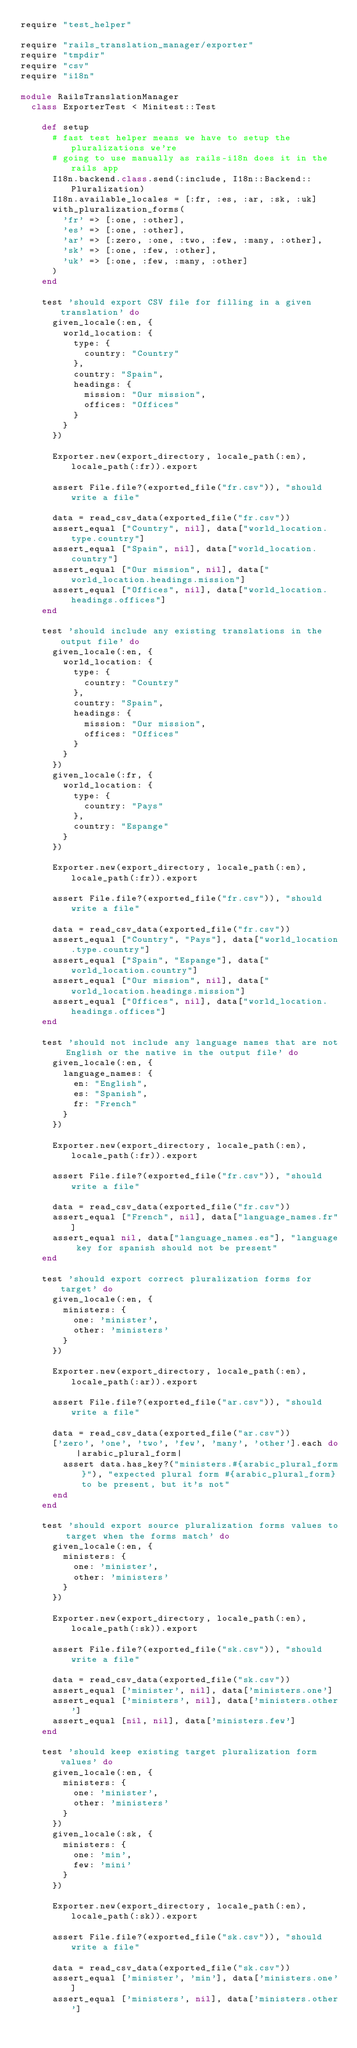Convert code to text. <code><loc_0><loc_0><loc_500><loc_500><_Ruby_>require "test_helper"

require "rails_translation_manager/exporter"
require "tmpdir"
require "csv"
require "i18n"

module RailsTranslationManager
  class ExporterTest < Minitest::Test

    def setup
      # fast test helper means we have to setup the pluralizations we're
      # going to use manually as rails-i18n does it in the rails app
      I18n.backend.class.send(:include, I18n::Backend::Pluralization)
      I18n.available_locales = [:fr, :es, :ar, :sk, :uk]
      with_pluralization_forms(
        'fr' => [:one, :other],
        'es' => [:one, :other],
        'ar' => [:zero, :one, :two, :few, :many, :other],
        'sk' => [:one, :few, :other],
        'uk' => [:one, :few, :many, :other]
      )
    end

    test 'should export CSV file for filling in a given translation' do
      given_locale(:en, {
        world_location: {
          type: {
            country: "Country"
          },
          country: "Spain",
          headings: {
            mission: "Our mission",
            offices: "Offices"
          }
        }
      })

      Exporter.new(export_directory, locale_path(:en), locale_path(:fr)).export

      assert File.file?(exported_file("fr.csv")), "should write a file"

      data = read_csv_data(exported_file("fr.csv"))
      assert_equal ["Country", nil], data["world_location.type.country"]
      assert_equal ["Spain", nil], data["world_location.country"]
      assert_equal ["Our mission", nil], data["world_location.headings.mission"]
      assert_equal ["Offices", nil], data["world_location.headings.offices"]
    end

    test 'should include any existing translations in the output file' do
      given_locale(:en, {
        world_location: {
          type: {
            country: "Country"
          },
          country: "Spain",
          headings: {
            mission: "Our mission",
            offices: "Offices"
          }
        }
      })
      given_locale(:fr, {
        world_location: {
          type: {
            country: "Pays"
          },
          country: "Espange"
        }
      })

      Exporter.new(export_directory, locale_path(:en), locale_path(:fr)).export

      assert File.file?(exported_file("fr.csv")), "should write a file"

      data = read_csv_data(exported_file("fr.csv"))
      assert_equal ["Country", "Pays"], data["world_location.type.country"]
      assert_equal ["Spain", "Espange"], data["world_location.country"]
      assert_equal ["Our mission", nil], data["world_location.headings.mission"]
      assert_equal ["Offices", nil], data["world_location.headings.offices"]
    end

    test 'should not include any language names that are not English or the native in the output file' do
      given_locale(:en, {
        language_names: {
          en: "English",
          es: "Spanish",
          fr: "French"
        }
      })

      Exporter.new(export_directory, locale_path(:en), locale_path(:fr)).export

      assert File.file?(exported_file("fr.csv")), "should write a file"

      data = read_csv_data(exported_file("fr.csv"))
      assert_equal ["French", nil], data["language_names.fr"]
      assert_equal nil, data["language_names.es"], "language key for spanish should not be present"
    end

    test 'should export correct pluralization forms for target' do
      given_locale(:en, {
        ministers: {
          one: 'minister',
          other: 'ministers'
        }
      })

      Exporter.new(export_directory, locale_path(:en), locale_path(:ar)).export

      assert File.file?(exported_file("ar.csv")), "should write a file"

      data = read_csv_data(exported_file("ar.csv"))
      ['zero', 'one', 'two', 'few', 'many', 'other'].each do |arabic_plural_form|
        assert data.has_key?("ministers.#{arabic_plural_form}"), "expected plural form #{arabic_plural_form} to be present, but it's not"
      end
    end

    test 'should export source pluralization forms values to target when the forms match' do
      given_locale(:en, {
        ministers: {
          one: 'minister',
          other: 'ministers'
        }
      })

      Exporter.new(export_directory, locale_path(:en), locale_path(:sk)).export

      assert File.file?(exported_file("sk.csv")), "should write a file"

      data = read_csv_data(exported_file("sk.csv"))
      assert_equal ['minister', nil], data['ministers.one']
      assert_equal ['ministers', nil], data['ministers.other']
      assert_equal [nil, nil], data['ministers.few']
    end

    test 'should keep existing target pluralization form values' do
      given_locale(:en, {
        ministers: {
          one: 'minister',
          other: 'ministers'
        }
      })
      given_locale(:sk, {
        ministers: {
          one: 'min',
          few: 'mini'
        }
      })

      Exporter.new(export_directory, locale_path(:en), locale_path(:sk)).export

      assert File.file?(exported_file("sk.csv")), "should write a file"

      data = read_csv_data(exported_file("sk.csv"))
      assert_equal ['minister', 'min'], data['ministers.one']
      assert_equal ['ministers', nil], data['ministers.other']</code> 